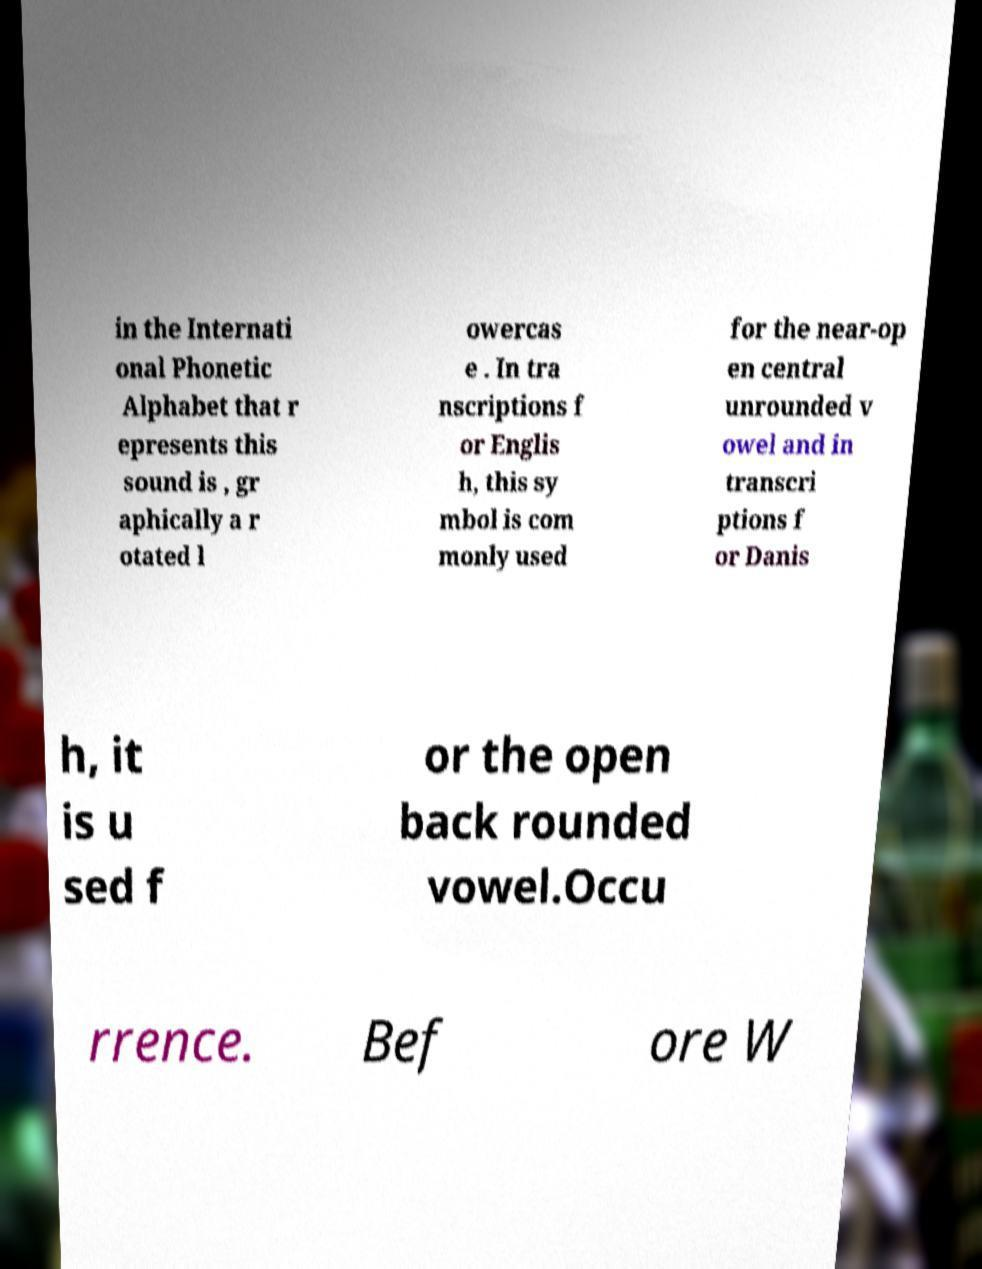There's text embedded in this image that I need extracted. Can you transcribe it verbatim? in the Internati onal Phonetic Alphabet that r epresents this sound is , gr aphically a r otated l owercas e . In tra nscriptions f or Englis h, this sy mbol is com monly used for the near-op en central unrounded v owel and in transcri ptions f or Danis h, it is u sed f or the open back rounded vowel.Occu rrence. Bef ore W 